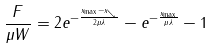Convert formula to latex. <formula><loc_0><loc_0><loc_500><loc_500>\frac { F } { \mu W } = 2 e ^ { - \frac { x _ { \max } - x _ { \searrow } } { 2 \mu \lambda } } - e ^ { - \frac { x _ { \max } } { \mu \lambda } } - 1</formula> 